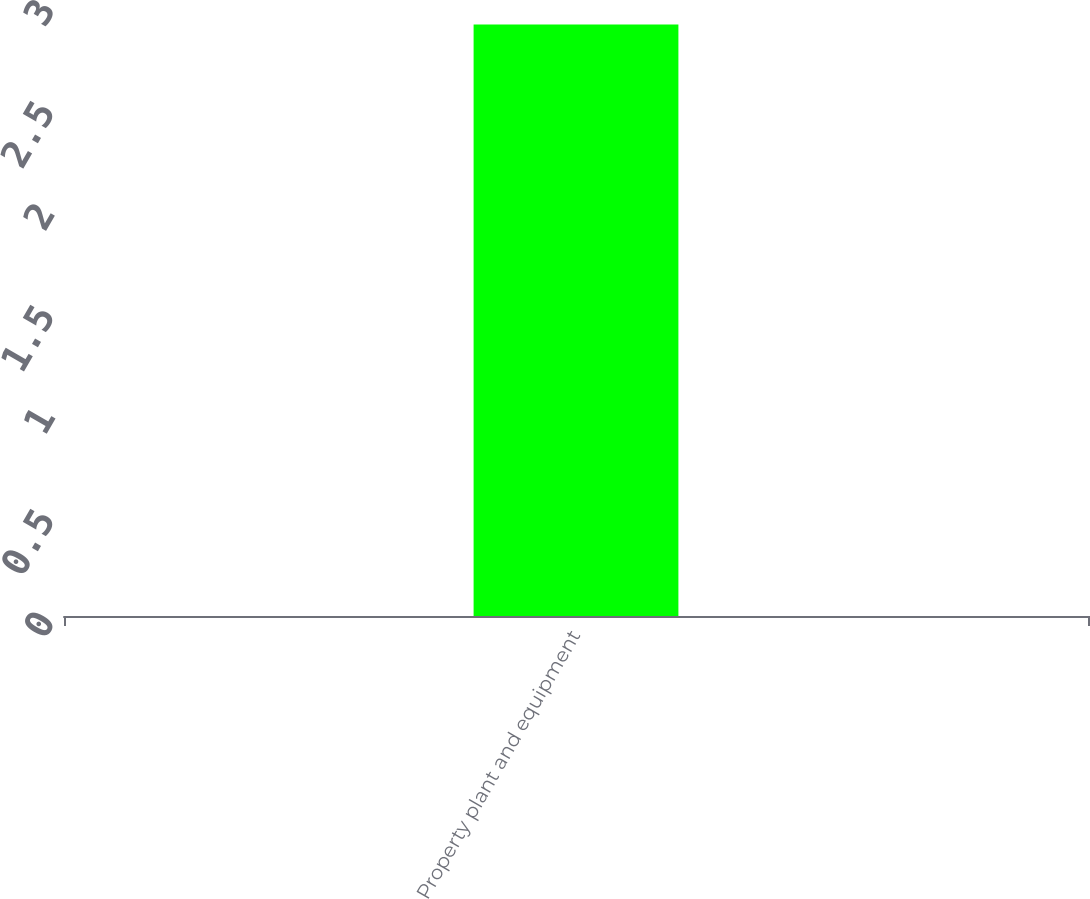<chart> <loc_0><loc_0><loc_500><loc_500><bar_chart><fcel>Property plant and equipment<nl><fcel>2.9<nl></chart> 